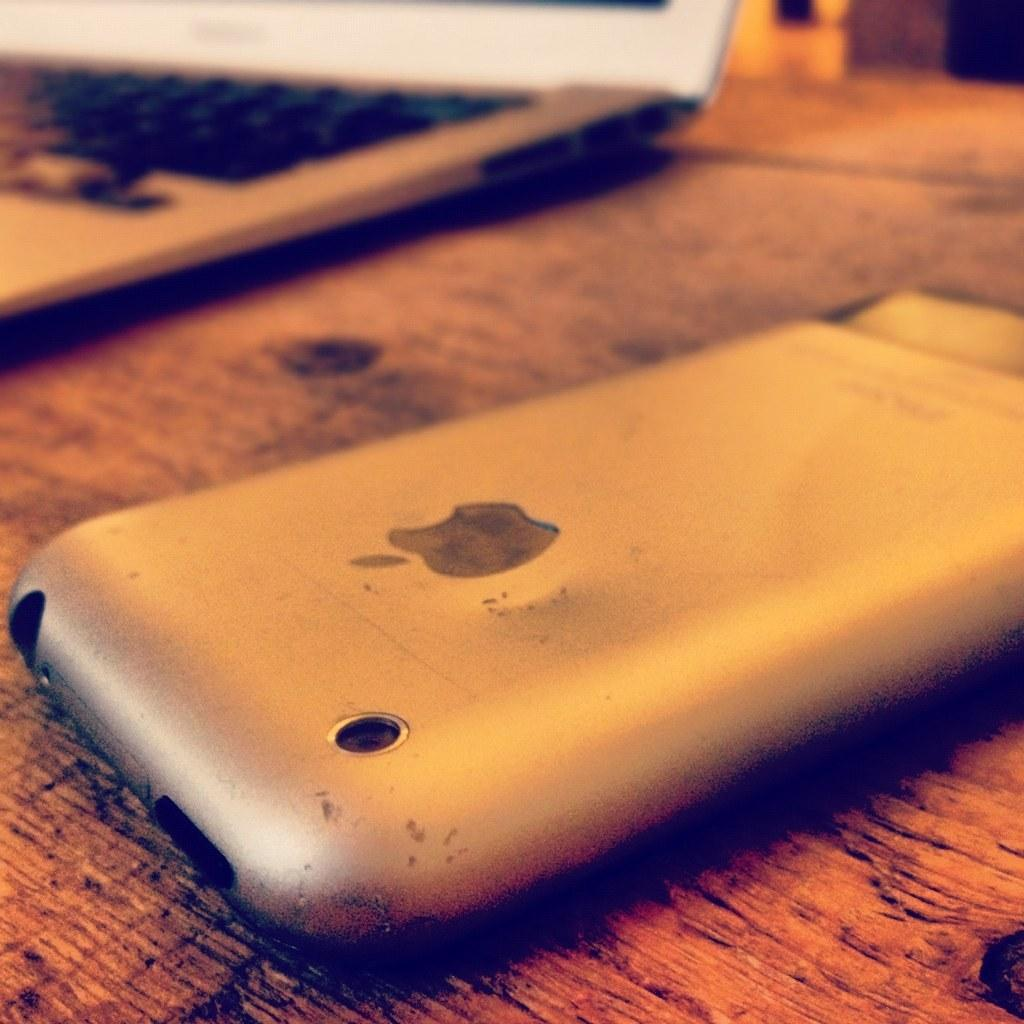What electronic device can be seen in the image? There is a laptop in the image. What other electronic device is present in the image? There is a mobile phone in the image. Where are the devices placed in the image? Both devices are placed on the ground. How much salt is visible on the ground next to the laptop? There is no salt visible in the image; only the laptop and mobile phone are present on the ground. 